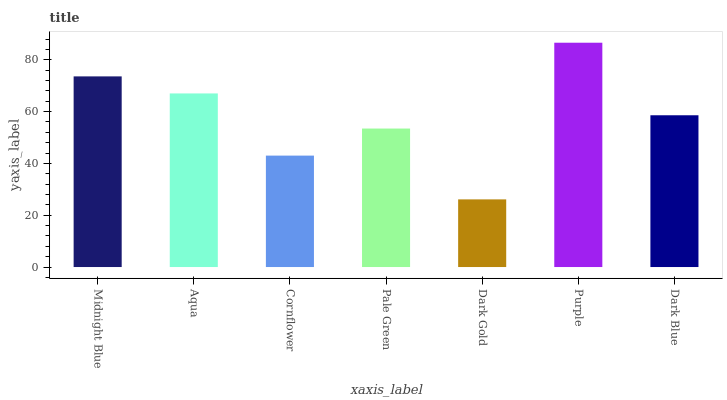Is Dark Gold the minimum?
Answer yes or no. Yes. Is Purple the maximum?
Answer yes or no. Yes. Is Aqua the minimum?
Answer yes or no. No. Is Aqua the maximum?
Answer yes or no. No. Is Midnight Blue greater than Aqua?
Answer yes or no. Yes. Is Aqua less than Midnight Blue?
Answer yes or no. Yes. Is Aqua greater than Midnight Blue?
Answer yes or no. No. Is Midnight Blue less than Aqua?
Answer yes or no. No. Is Dark Blue the high median?
Answer yes or no. Yes. Is Dark Blue the low median?
Answer yes or no. Yes. Is Dark Gold the high median?
Answer yes or no. No. Is Pale Green the low median?
Answer yes or no. No. 